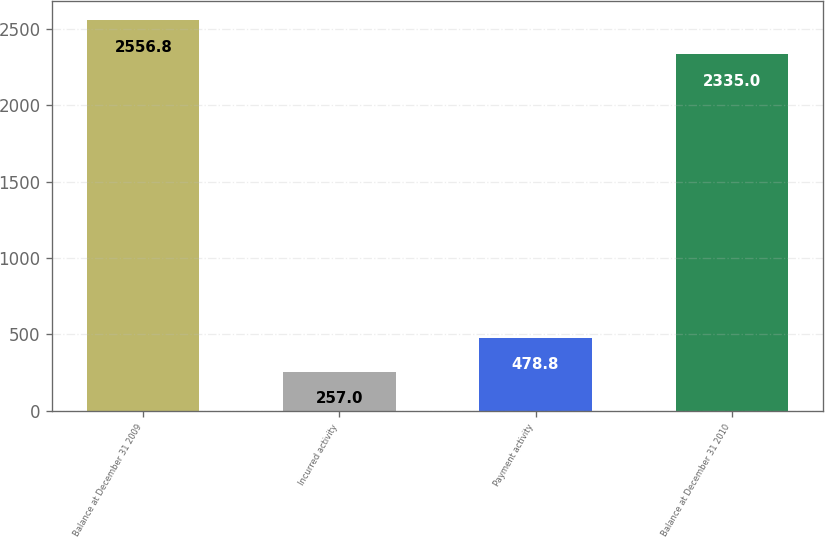Convert chart. <chart><loc_0><loc_0><loc_500><loc_500><bar_chart><fcel>Balance at December 31 2009<fcel>Incurred activity<fcel>Payment activity<fcel>Balance at December 31 2010<nl><fcel>2556.8<fcel>257<fcel>478.8<fcel>2335<nl></chart> 